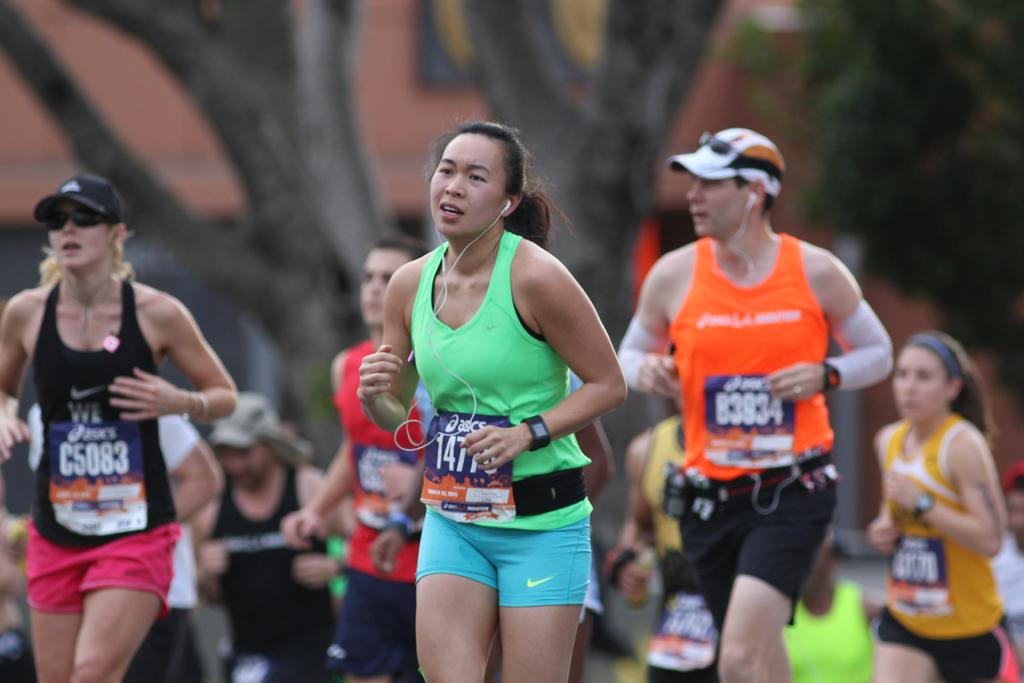<image>
Give a short and clear explanation of the subsequent image. a runner has the number 147 on the front of their sign 